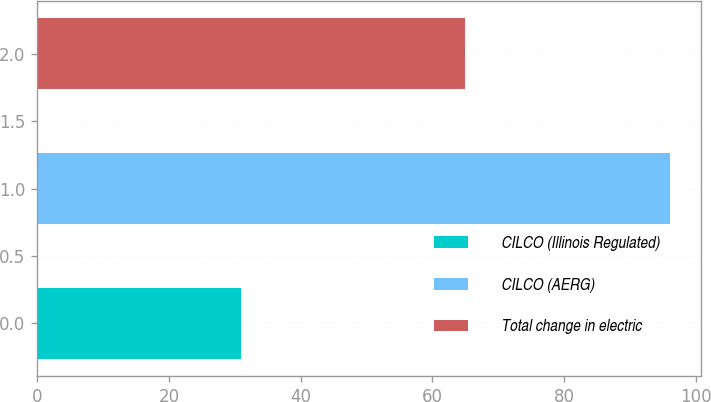Convert chart. <chart><loc_0><loc_0><loc_500><loc_500><bar_chart><fcel>CILCO (Illinois Regulated)<fcel>CILCO (AERG)<fcel>Total change in electric<nl><fcel>31<fcel>96<fcel>65<nl></chart> 